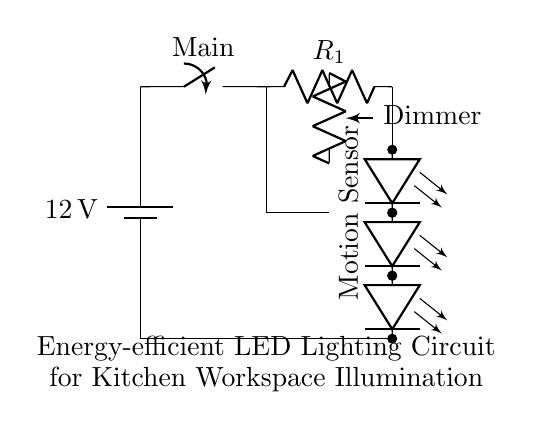What is the voltage of the power supply? The circuit shows a battery supply labeled as 12 volts, indicating the potential difference provided to the circuit.
Answer: 12 volts What does the motion sensor do in this circuit? The motion sensor detects movement and, when activated, allows current to flow to the LED array for illumination, contributing to energy efficiency by ensuring lights are only on when needed.
Answer: Detects movement How many LEDs are in the array? The diagram illustrates three LED units connected in series, as depicted by the multiple led symbols in succession along the vertical line.
Answer: Three What is the function of the resistor R1? The resistor R1 is a current limiting resistor that restricts the flow of current through the LEDs, preventing them from drawing too much current, which could cause damage.
Answer: Current limiting What component can adjust the brightness in this circuit? The circuit includes a dimmer labeled as a variable resistor, allowing the user to change the resistance and thereby control the voltage across the LED array, adjusting the brightness accordingly.
Answer: Dimmer Why is this circuit considered energy-efficient? The circuit utilizes LED technology which consumes significantly less power than traditional incandescent or fluorescent lighting and is paired with the motion sensor to limit lighting use only to times when needed.
Answer: Energy-efficient 